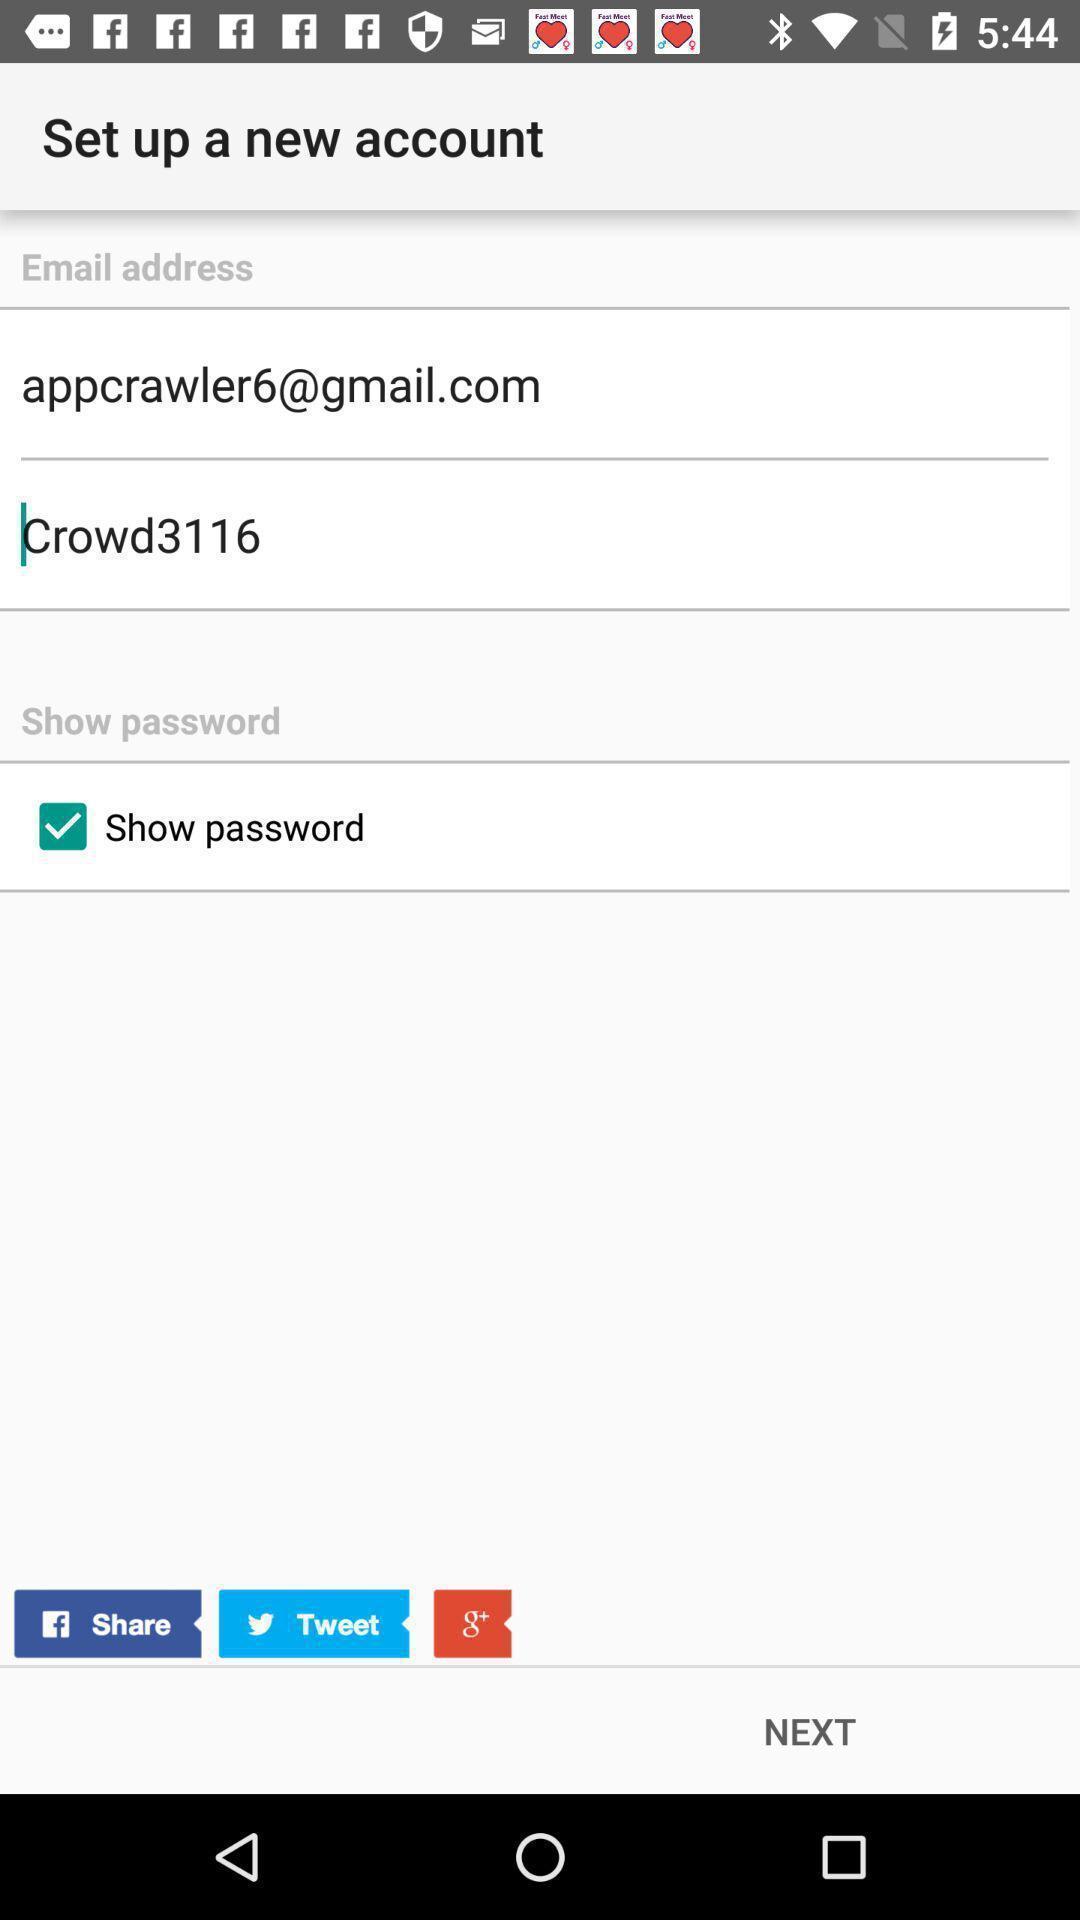Explain what's happening in this screen capture. Signup page of a social app. 